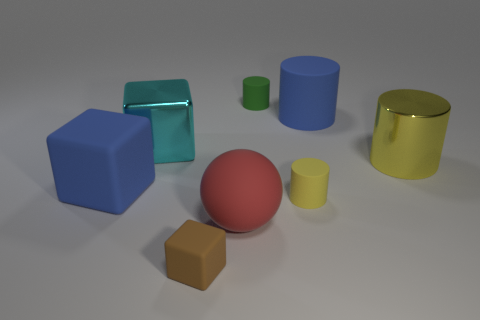Do the big blue thing that is on the right side of the large blue block and the small rubber thing that is right of the green cylinder have the same shape? Yes, both objects you're referring to are cylindrical. The larger blue object on the right of the big blue block is indeed a cylinder, and the smaller rubber object to the right of the green cylinder also has a cylindrical shape, although it's smaller in size. 